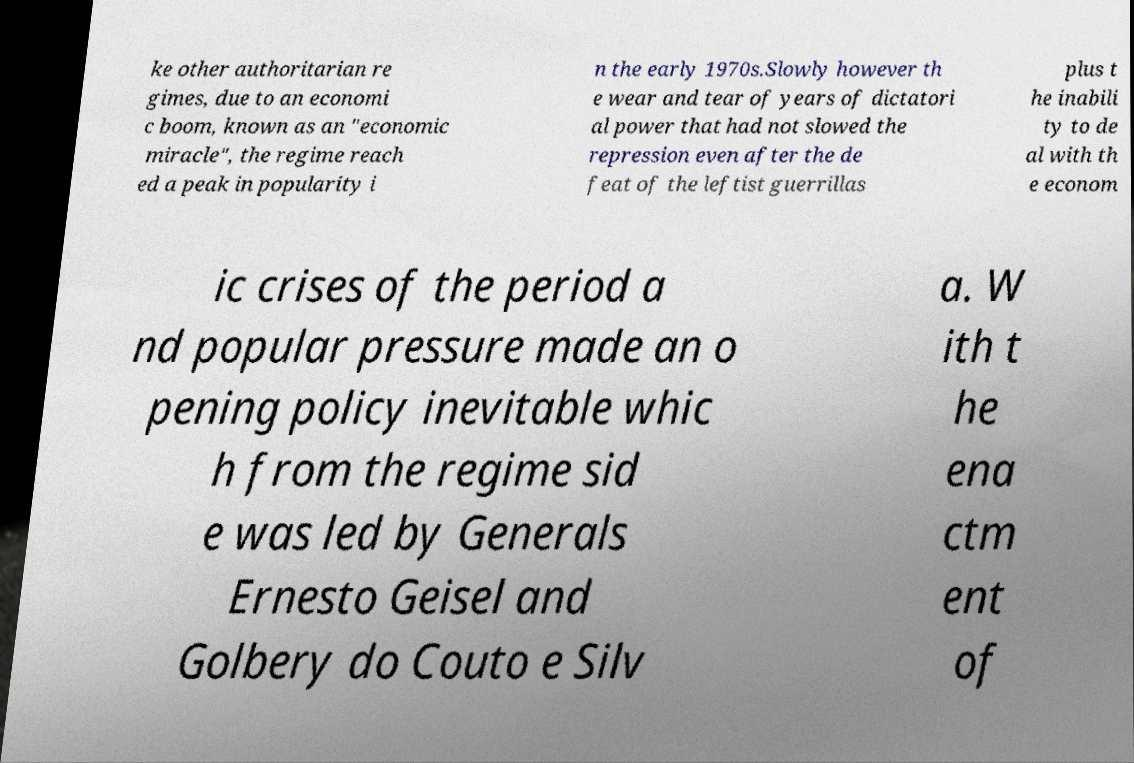I need the written content from this picture converted into text. Can you do that? ke other authoritarian re gimes, due to an economi c boom, known as an "economic miracle", the regime reach ed a peak in popularity i n the early 1970s.Slowly however th e wear and tear of years of dictatori al power that had not slowed the repression even after the de feat of the leftist guerrillas plus t he inabili ty to de al with th e econom ic crises of the period a nd popular pressure made an o pening policy inevitable whic h from the regime sid e was led by Generals Ernesto Geisel and Golbery do Couto e Silv a. W ith t he ena ctm ent of 